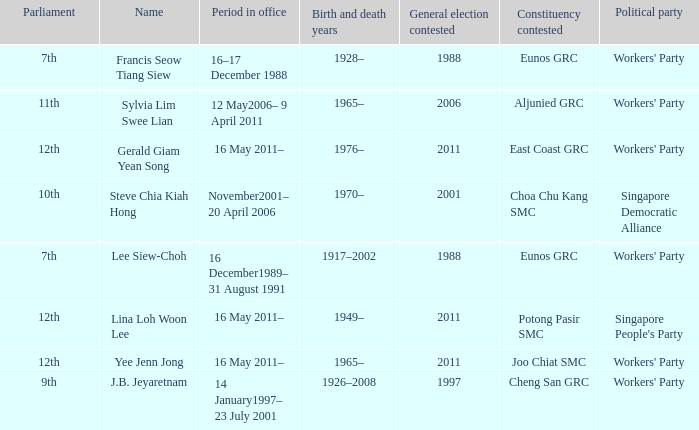What number parliament held it's election in 1997? 9th. Parse the table in full. {'header': ['Parliament', 'Name', 'Period in office', 'Birth and death years', 'General election contested', 'Constituency contested', 'Political party'], 'rows': [['7th', 'Francis Seow Tiang Siew', '16–17 December 1988', '1928–', '1988', 'Eunos GRC', "Workers' Party"], ['11th', 'Sylvia Lim Swee Lian', '12 May2006– 9 April 2011', '1965–', '2006', 'Aljunied GRC', "Workers' Party"], ['12th', 'Gerald Giam Yean Song', '16 May 2011–', '1976–', '2011', 'East Coast GRC', "Workers' Party"], ['10th', 'Steve Chia Kiah Hong', 'November2001– 20 April 2006', '1970–', '2001', 'Choa Chu Kang SMC', 'Singapore Democratic Alliance'], ['7th', 'Lee Siew-Choh', '16 December1989– 31 August 1991', '1917–2002', '1988', 'Eunos GRC', "Workers' Party"], ['12th', 'Lina Loh Woon Lee', '16 May 2011–', '1949–', '2011', 'Potong Pasir SMC', "Singapore People's Party"], ['12th', 'Yee Jenn Jong', '16 May 2011–', '1965–', '2011', 'Joo Chiat SMC', "Workers' Party"], ['9th', 'J.B. Jeyaretnam', '14 January1997– 23 July 2001', '1926–2008', '1997', 'Cheng San GRC', "Workers' Party"]]} 